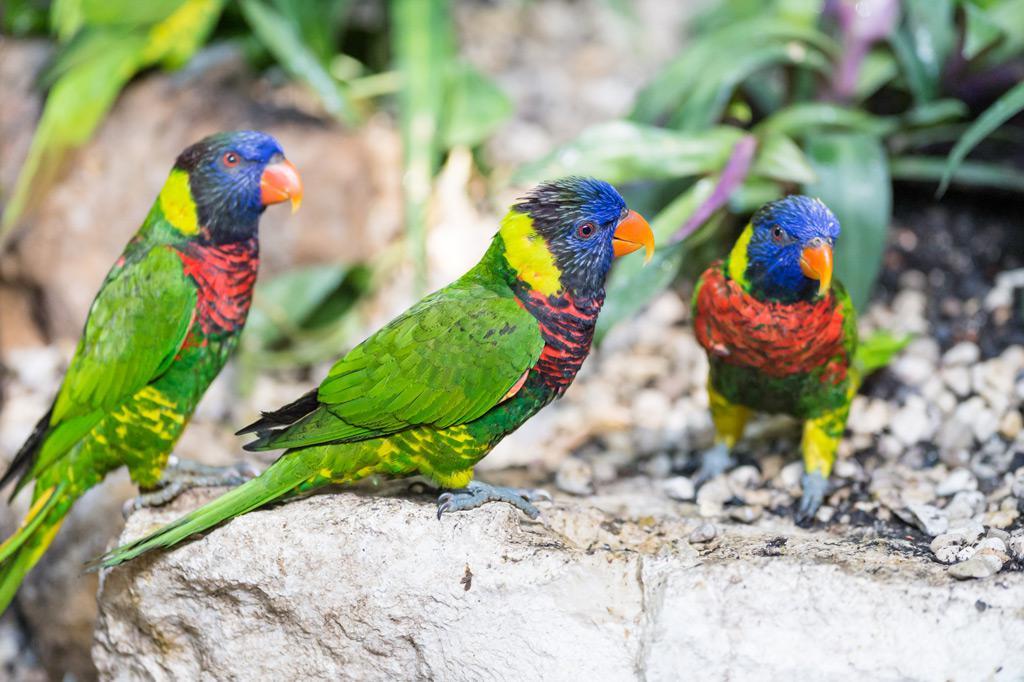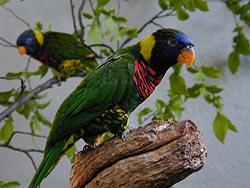The first image is the image on the left, the second image is the image on the right. Considering the images on both sides, is "The left image shows exactly three multicolored parrots." valid? Answer yes or no. Yes. 